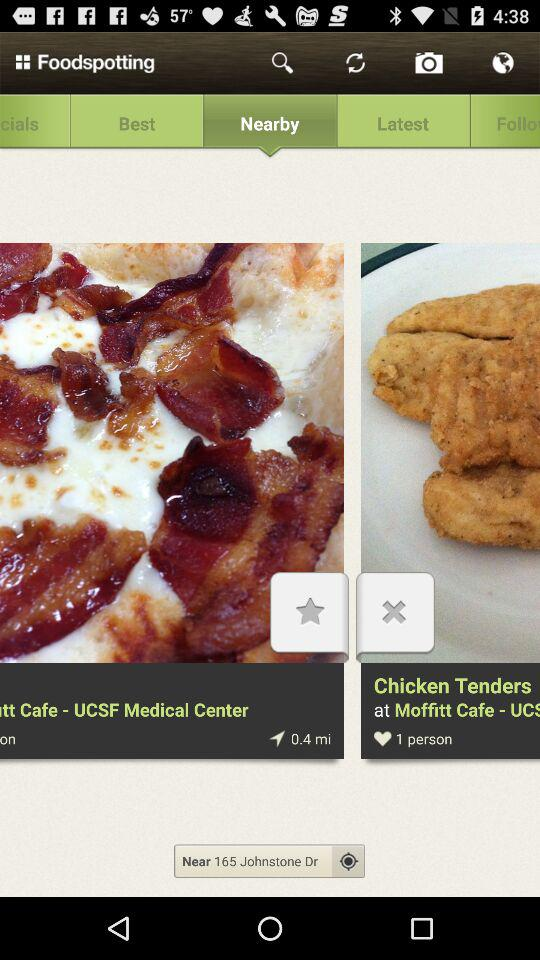Which tab is open? The open tab is "Nearby". 